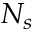Convert formula to latex. <formula><loc_0><loc_0><loc_500><loc_500>N _ { s }</formula> 